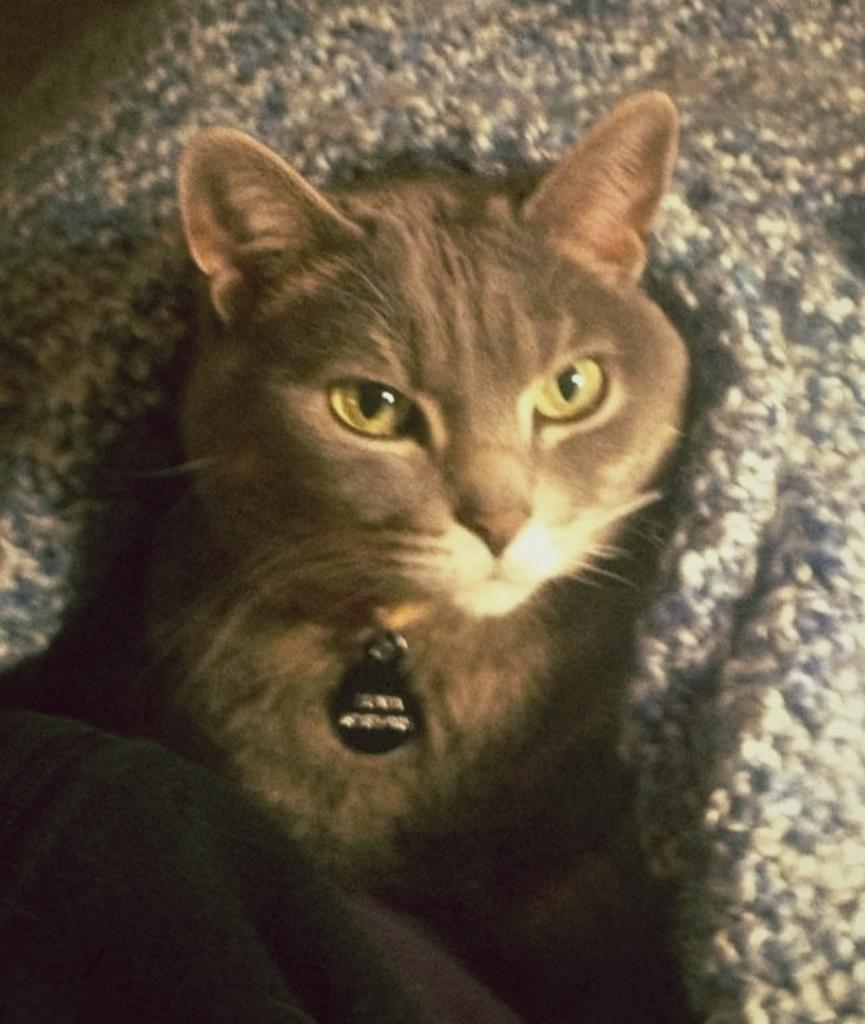What type of animal is in the image? There is a brown color cat in the image. How is the cat positioned in the image? The cat is looking into the camera. What other object can be seen in the image? There is a cloth in the image. What type of thread is being used by the cat in the image? There is no thread present in the image, and the cat is not using any thread. 